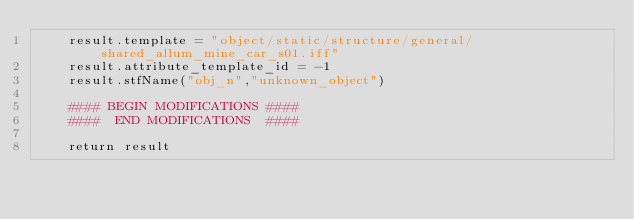Convert code to text. <code><loc_0><loc_0><loc_500><loc_500><_Python_>	result.template = "object/static/structure/general/shared_allum_mine_car_s01.iff"
	result.attribute_template_id = -1
	result.stfName("obj_n","unknown_object")		
	
	#### BEGIN MODIFICATIONS ####
	####  END MODIFICATIONS  ####
	
	return result</code> 